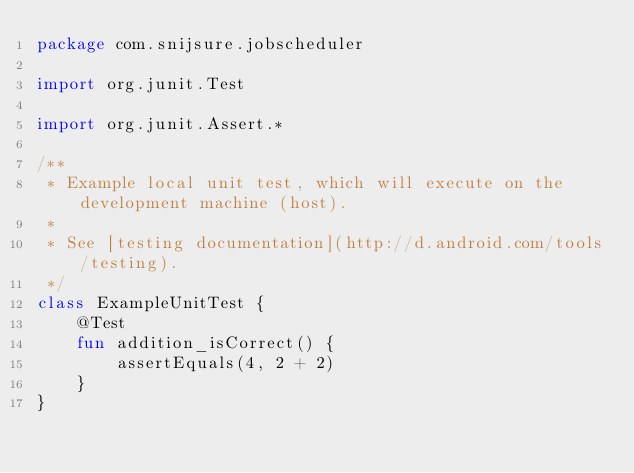Convert code to text. <code><loc_0><loc_0><loc_500><loc_500><_Kotlin_>package com.snijsure.jobscheduler

import org.junit.Test

import org.junit.Assert.*

/**
 * Example local unit test, which will execute on the development machine (host).
 *
 * See [testing documentation](http://d.android.com/tools/testing).
 */
class ExampleUnitTest {
    @Test
    fun addition_isCorrect() {
        assertEquals(4, 2 + 2)
    }
}
</code> 